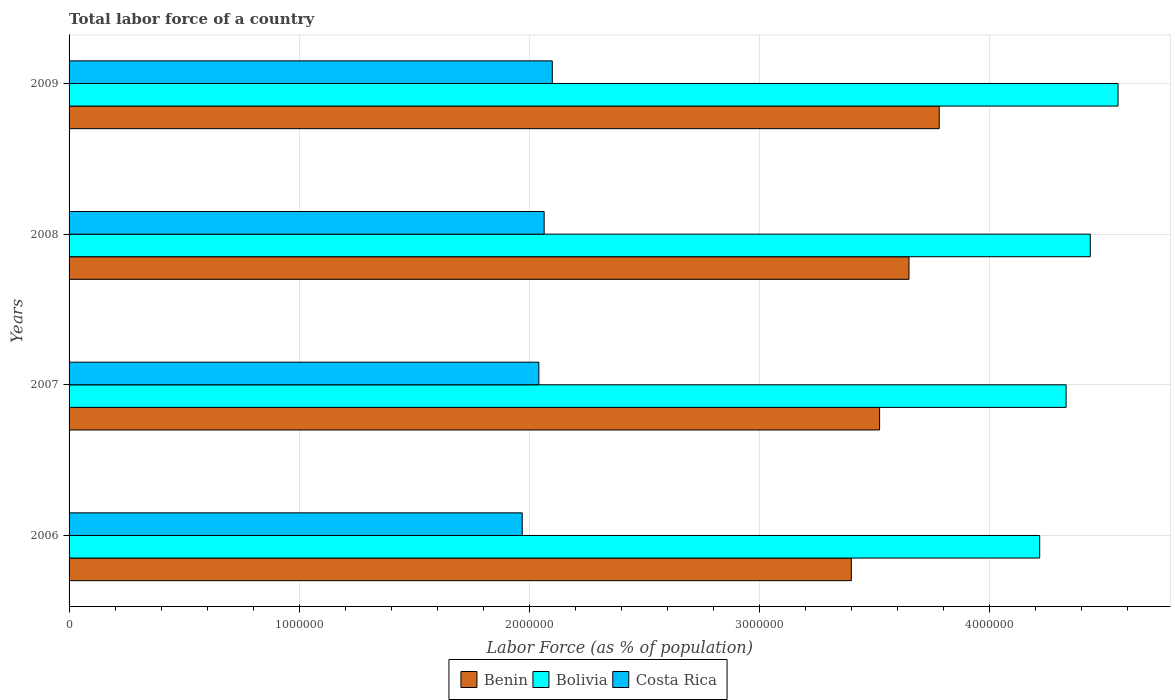How many different coloured bars are there?
Provide a short and direct response. 3. How many groups of bars are there?
Offer a very short reply. 4. How many bars are there on the 2nd tick from the top?
Provide a succinct answer. 3. How many bars are there on the 1st tick from the bottom?
Make the answer very short. 3. What is the label of the 3rd group of bars from the top?
Make the answer very short. 2007. What is the percentage of labor force in Costa Rica in 2006?
Keep it short and to the point. 1.97e+06. Across all years, what is the maximum percentage of labor force in Costa Rica?
Provide a succinct answer. 2.10e+06. Across all years, what is the minimum percentage of labor force in Costa Rica?
Ensure brevity in your answer.  1.97e+06. What is the total percentage of labor force in Benin in the graph?
Provide a succinct answer. 1.44e+07. What is the difference between the percentage of labor force in Benin in 2006 and that in 2009?
Provide a succinct answer. -3.82e+05. What is the difference between the percentage of labor force in Costa Rica in 2009 and the percentage of labor force in Bolivia in 2007?
Make the answer very short. -2.23e+06. What is the average percentage of labor force in Bolivia per year?
Offer a very short reply. 4.39e+06. In the year 2009, what is the difference between the percentage of labor force in Costa Rica and percentage of labor force in Bolivia?
Ensure brevity in your answer.  -2.46e+06. In how many years, is the percentage of labor force in Bolivia greater than 600000 %?
Ensure brevity in your answer.  4. What is the ratio of the percentage of labor force in Benin in 2007 to that in 2009?
Your answer should be very brief. 0.93. What is the difference between the highest and the second highest percentage of labor force in Benin?
Provide a succinct answer. 1.31e+05. What is the difference between the highest and the lowest percentage of labor force in Bolivia?
Keep it short and to the point. 3.41e+05. What does the 3rd bar from the top in 2006 represents?
Your answer should be compact. Benin. How many bars are there?
Your answer should be very brief. 12. Are all the bars in the graph horizontal?
Provide a succinct answer. Yes. Does the graph contain any zero values?
Provide a succinct answer. No. Does the graph contain grids?
Ensure brevity in your answer.  Yes. Where does the legend appear in the graph?
Keep it short and to the point. Bottom center. How are the legend labels stacked?
Give a very brief answer. Horizontal. What is the title of the graph?
Offer a very short reply. Total labor force of a country. Does "Lower middle income" appear as one of the legend labels in the graph?
Make the answer very short. No. What is the label or title of the X-axis?
Provide a succinct answer. Labor Force (as % of population). What is the label or title of the Y-axis?
Your answer should be compact. Years. What is the Labor Force (as % of population) in Benin in 2006?
Give a very brief answer. 3.40e+06. What is the Labor Force (as % of population) of Bolivia in 2006?
Offer a very short reply. 4.22e+06. What is the Labor Force (as % of population) in Costa Rica in 2006?
Offer a very short reply. 1.97e+06. What is the Labor Force (as % of population) in Benin in 2007?
Keep it short and to the point. 3.52e+06. What is the Labor Force (as % of population) in Bolivia in 2007?
Make the answer very short. 4.33e+06. What is the Labor Force (as % of population) in Costa Rica in 2007?
Keep it short and to the point. 2.04e+06. What is the Labor Force (as % of population) in Benin in 2008?
Give a very brief answer. 3.65e+06. What is the Labor Force (as % of population) of Bolivia in 2008?
Ensure brevity in your answer.  4.44e+06. What is the Labor Force (as % of population) in Costa Rica in 2008?
Keep it short and to the point. 2.06e+06. What is the Labor Force (as % of population) of Benin in 2009?
Provide a succinct answer. 3.78e+06. What is the Labor Force (as % of population) of Bolivia in 2009?
Provide a short and direct response. 4.56e+06. What is the Labor Force (as % of population) of Costa Rica in 2009?
Your answer should be very brief. 2.10e+06. Across all years, what is the maximum Labor Force (as % of population) in Benin?
Ensure brevity in your answer.  3.78e+06. Across all years, what is the maximum Labor Force (as % of population) in Bolivia?
Provide a short and direct response. 4.56e+06. Across all years, what is the maximum Labor Force (as % of population) of Costa Rica?
Provide a short and direct response. 2.10e+06. Across all years, what is the minimum Labor Force (as % of population) in Benin?
Offer a terse response. 3.40e+06. Across all years, what is the minimum Labor Force (as % of population) of Bolivia?
Provide a short and direct response. 4.22e+06. Across all years, what is the minimum Labor Force (as % of population) of Costa Rica?
Your response must be concise. 1.97e+06. What is the total Labor Force (as % of population) in Benin in the graph?
Offer a very short reply. 1.44e+07. What is the total Labor Force (as % of population) of Bolivia in the graph?
Your answer should be very brief. 1.75e+07. What is the total Labor Force (as % of population) of Costa Rica in the graph?
Your response must be concise. 8.18e+06. What is the difference between the Labor Force (as % of population) of Benin in 2006 and that in 2007?
Ensure brevity in your answer.  -1.23e+05. What is the difference between the Labor Force (as % of population) of Bolivia in 2006 and that in 2007?
Ensure brevity in your answer.  -1.15e+05. What is the difference between the Labor Force (as % of population) of Costa Rica in 2006 and that in 2007?
Your answer should be very brief. -7.23e+04. What is the difference between the Labor Force (as % of population) in Benin in 2006 and that in 2008?
Provide a short and direct response. -2.51e+05. What is the difference between the Labor Force (as % of population) of Bolivia in 2006 and that in 2008?
Keep it short and to the point. -2.20e+05. What is the difference between the Labor Force (as % of population) of Costa Rica in 2006 and that in 2008?
Offer a very short reply. -9.53e+04. What is the difference between the Labor Force (as % of population) of Benin in 2006 and that in 2009?
Make the answer very short. -3.82e+05. What is the difference between the Labor Force (as % of population) of Bolivia in 2006 and that in 2009?
Provide a short and direct response. -3.41e+05. What is the difference between the Labor Force (as % of population) of Costa Rica in 2006 and that in 2009?
Give a very brief answer. -1.31e+05. What is the difference between the Labor Force (as % of population) in Benin in 2007 and that in 2008?
Keep it short and to the point. -1.28e+05. What is the difference between the Labor Force (as % of population) in Bolivia in 2007 and that in 2008?
Your answer should be compact. -1.05e+05. What is the difference between the Labor Force (as % of population) in Costa Rica in 2007 and that in 2008?
Offer a very short reply. -2.29e+04. What is the difference between the Labor Force (as % of population) of Benin in 2007 and that in 2009?
Ensure brevity in your answer.  -2.59e+05. What is the difference between the Labor Force (as % of population) of Bolivia in 2007 and that in 2009?
Offer a terse response. -2.26e+05. What is the difference between the Labor Force (as % of population) of Costa Rica in 2007 and that in 2009?
Ensure brevity in your answer.  -5.84e+04. What is the difference between the Labor Force (as % of population) in Benin in 2008 and that in 2009?
Your answer should be very brief. -1.31e+05. What is the difference between the Labor Force (as % of population) of Bolivia in 2008 and that in 2009?
Ensure brevity in your answer.  -1.21e+05. What is the difference between the Labor Force (as % of population) of Costa Rica in 2008 and that in 2009?
Your response must be concise. -3.54e+04. What is the difference between the Labor Force (as % of population) in Benin in 2006 and the Labor Force (as % of population) in Bolivia in 2007?
Your answer should be very brief. -9.34e+05. What is the difference between the Labor Force (as % of population) of Benin in 2006 and the Labor Force (as % of population) of Costa Rica in 2007?
Provide a short and direct response. 1.36e+06. What is the difference between the Labor Force (as % of population) of Bolivia in 2006 and the Labor Force (as % of population) of Costa Rica in 2007?
Provide a short and direct response. 2.18e+06. What is the difference between the Labor Force (as % of population) of Benin in 2006 and the Labor Force (as % of population) of Bolivia in 2008?
Your answer should be compact. -1.04e+06. What is the difference between the Labor Force (as % of population) of Benin in 2006 and the Labor Force (as % of population) of Costa Rica in 2008?
Your answer should be very brief. 1.34e+06. What is the difference between the Labor Force (as % of population) in Bolivia in 2006 and the Labor Force (as % of population) in Costa Rica in 2008?
Your response must be concise. 2.15e+06. What is the difference between the Labor Force (as % of population) in Benin in 2006 and the Labor Force (as % of population) in Bolivia in 2009?
Offer a terse response. -1.16e+06. What is the difference between the Labor Force (as % of population) in Benin in 2006 and the Labor Force (as % of population) in Costa Rica in 2009?
Give a very brief answer. 1.30e+06. What is the difference between the Labor Force (as % of population) of Bolivia in 2006 and the Labor Force (as % of population) of Costa Rica in 2009?
Make the answer very short. 2.12e+06. What is the difference between the Labor Force (as % of population) of Benin in 2007 and the Labor Force (as % of population) of Bolivia in 2008?
Keep it short and to the point. -9.16e+05. What is the difference between the Labor Force (as % of population) of Benin in 2007 and the Labor Force (as % of population) of Costa Rica in 2008?
Your answer should be compact. 1.46e+06. What is the difference between the Labor Force (as % of population) in Bolivia in 2007 and the Labor Force (as % of population) in Costa Rica in 2008?
Ensure brevity in your answer.  2.27e+06. What is the difference between the Labor Force (as % of population) of Benin in 2007 and the Labor Force (as % of population) of Bolivia in 2009?
Provide a succinct answer. -1.04e+06. What is the difference between the Labor Force (as % of population) of Benin in 2007 and the Labor Force (as % of population) of Costa Rica in 2009?
Keep it short and to the point. 1.42e+06. What is the difference between the Labor Force (as % of population) of Bolivia in 2007 and the Labor Force (as % of population) of Costa Rica in 2009?
Give a very brief answer. 2.23e+06. What is the difference between the Labor Force (as % of population) of Benin in 2008 and the Labor Force (as % of population) of Bolivia in 2009?
Your response must be concise. -9.09e+05. What is the difference between the Labor Force (as % of population) in Benin in 2008 and the Labor Force (as % of population) in Costa Rica in 2009?
Your answer should be compact. 1.55e+06. What is the difference between the Labor Force (as % of population) in Bolivia in 2008 and the Labor Force (as % of population) in Costa Rica in 2009?
Your answer should be compact. 2.34e+06. What is the average Labor Force (as % of population) in Benin per year?
Provide a succinct answer. 3.59e+06. What is the average Labor Force (as % of population) in Bolivia per year?
Provide a short and direct response. 4.39e+06. What is the average Labor Force (as % of population) in Costa Rica per year?
Your response must be concise. 2.04e+06. In the year 2006, what is the difference between the Labor Force (as % of population) of Benin and Labor Force (as % of population) of Bolivia?
Provide a succinct answer. -8.19e+05. In the year 2006, what is the difference between the Labor Force (as % of population) of Benin and Labor Force (as % of population) of Costa Rica?
Ensure brevity in your answer.  1.43e+06. In the year 2006, what is the difference between the Labor Force (as % of population) in Bolivia and Labor Force (as % of population) in Costa Rica?
Provide a succinct answer. 2.25e+06. In the year 2007, what is the difference between the Labor Force (as % of population) in Benin and Labor Force (as % of population) in Bolivia?
Offer a very short reply. -8.11e+05. In the year 2007, what is the difference between the Labor Force (as % of population) of Benin and Labor Force (as % of population) of Costa Rica?
Provide a succinct answer. 1.48e+06. In the year 2007, what is the difference between the Labor Force (as % of population) in Bolivia and Labor Force (as % of population) in Costa Rica?
Offer a very short reply. 2.29e+06. In the year 2008, what is the difference between the Labor Force (as % of population) of Benin and Labor Force (as % of population) of Bolivia?
Provide a succinct answer. -7.88e+05. In the year 2008, what is the difference between the Labor Force (as % of population) of Benin and Labor Force (as % of population) of Costa Rica?
Give a very brief answer. 1.59e+06. In the year 2008, what is the difference between the Labor Force (as % of population) of Bolivia and Labor Force (as % of population) of Costa Rica?
Provide a short and direct response. 2.37e+06. In the year 2009, what is the difference between the Labor Force (as % of population) in Benin and Labor Force (as % of population) in Bolivia?
Your answer should be very brief. -7.77e+05. In the year 2009, what is the difference between the Labor Force (as % of population) in Benin and Labor Force (as % of population) in Costa Rica?
Give a very brief answer. 1.68e+06. In the year 2009, what is the difference between the Labor Force (as % of population) of Bolivia and Labor Force (as % of population) of Costa Rica?
Keep it short and to the point. 2.46e+06. What is the ratio of the Labor Force (as % of population) in Benin in 2006 to that in 2007?
Offer a very short reply. 0.97. What is the ratio of the Labor Force (as % of population) of Bolivia in 2006 to that in 2007?
Your response must be concise. 0.97. What is the ratio of the Labor Force (as % of population) of Costa Rica in 2006 to that in 2007?
Your answer should be compact. 0.96. What is the ratio of the Labor Force (as % of population) of Benin in 2006 to that in 2008?
Ensure brevity in your answer.  0.93. What is the ratio of the Labor Force (as % of population) in Bolivia in 2006 to that in 2008?
Provide a short and direct response. 0.95. What is the ratio of the Labor Force (as % of population) of Costa Rica in 2006 to that in 2008?
Your response must be concise. 0.95. What is the ratio of the Labor Force (as % of population) of Benin in 2006 to that in 2009?
Ensure brevity in your answer.  0.9. What is the ratio of the Labor Force (as % of population) of Bolivia in 2006 to that in 2009?
Provide a short and direct response. 0.93. What is the ratio of the Labor Force (as % of population) of Costa Rica in 2006 to that in 2009?
Offer a terse response. 0.94. What is the ratio of the Labor Force (as % of population) of Benin in 2007 to that in 2008?
Offer a terse response. 0.96. What is the ratio of the Labor Force (as % of population) in Bolivia in 2007 to that in 2008?
Your response must be concise. 0.98. What is the ratio of the Labor Force (as % of population) of Costa Rica in 2007 to that in 2008?
Offer a terse response. 0.99. What is the ratio of the Labor Force (as % of population) of Benin in 2007 to that in 2009?
Offer a terse response. 0.93. What is the ratio of the Labor Force (as % of population) in Bolivia in 2007 to that in 2009?
Offer a terse response. 0.95. What is the ratio of the Labor Force (as % of population) of Costa Rica in 2007 to that in 2009?
Keep it short and to the point. 0.97. What is the ratio of the Labor Force (as % of population) in Benin in 2008 to that in 2009?
Provide a short and direct response. 0.97. What is the ratio of the Labor Force (as % of population) in Bolivia in 2008 to that in 2009?
Your response must be concise. 0.97. What is the ratio of the Labor Force (as % of population) of Costa Rica in 2008 to that in 2009?
Offer a very short reply. 0.98. What is the difference between the highest and the second highest Labor Force (as % of population) of Benin?
Your answer should be very brief. 1.31e+05. What is the difference between the highest and the second highest Labor Force (as % of population) in Bolivia?
Make the answer very short. 1.21e+05. What is the difference between the highest and the second highest Labor Force (as % of population) in Costa Rica?
Your answer should be very brief. 3.54e+04. What is the difference between the highest and the lowest Labor Force (as % of population) in Benin?
Your response must be concise. 3.82e+05. What is the difference between the highest and the lowest Labor Force (as % of population) in Bolivia?
Offer a terse response. 3.41e+05. What is the difference between the highest and the lowest Labor Force (as % of population) in Costa Rica?
Ensure brevity in your answer.  1.31e+05. 